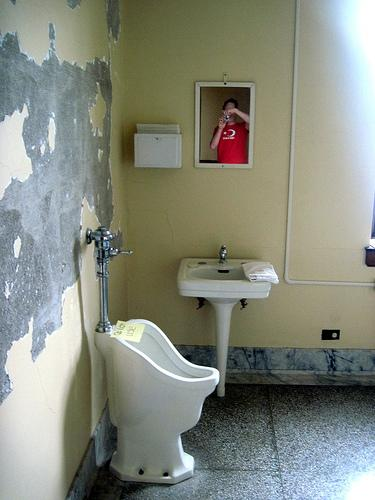Which object is doing an action and what is that action within the image description? The man in the mirror is performing the action of taking a photo. Provide a brief description of the scene in the image. The image shows a bathroom with a white urinal, a pedestal sink, a mirror, and a floor with grey patches. There is a yellow out-of-order sign on the urinal and a man's reflection in the mirror. Explain the appearance of the floor in the image using adjectives. The floor in this image is dark, speckled, and cracked, with grey patches. How many elements in the image description relate to the state of the wall and what are a few keywords relating to them? Six elements relate to the state of the wall: light-colored wall, wall with peeled paint, paint chipped on the wall, the water pipe on the wall, edge of the window sill, and grey mottled section of the wall. Keywords include light-colored, peeled, chipped, water pipe, window sill, and grey mottled. List any two objects and describe their interactions with another object in the image. 2. Bar of soap: resting on the sink, presumably used for washing hands. Describe the sentiments that could be associated with the image. Sentiments associated with the image may include disrepair, uncleanliness, and frustration, as the urinal is out of order and there is peeling paint on the walls. In one sentence, sum up what can be inferred from the image's reflection in the mirror. A man wearing a red t-shirt is taking a photo of the bathroom's reflection in the mirror. How many different objects are mentioned as being on the sink? Three objects are mentioned on the sink: bar of soap, folded towel, and a silver faucet. What is the main object visible in the image and in which corner of the image can it be primarily found? The main object visible is a white urinal, and it can be found at the left side of the image near the bottom. Count and mention how many objects are connected to the floor in the image. There are three objects connected to the floor: urinal, pedestal sink, and the faux marble wide baseboard. Identify the type of floor in the image. Speckled tiled floor Point out some objects you can see in the image. White urinal, pedestal sink, man's reflection in the mirror, towel, faucet, floor with gray patches, outlet, and paper towel holder. What do you notice about the condition of the wall in the image? There are chipped and peeling paint areas on the wall. Is the metal faucet for a sink or a urinal in the image? Sink Identify parts or sections of the wall in the image. Wall with peeled paint, gray mottled section of wall, and paint chipped on the wall. Locate the toothbrush and toothpaste lying beside the bar of soap on the sink. The image captions mention a bar of soap on the sink, but there is no mention of a toothbrush or toothpaste. This instruction is misleading because it directs users to find non-existent objects. Find the rubber duck sitting on the edge of the bathtub, and notice its vibrant yellow color. The image captions do not contain any information about a rubber duck or a bathtub, making this instruction misleading as it directs users to locate non-existent objects. What type of object can you find at the coordinates X:131 Y:460 Width:18 Height:18? Bolt holding toilet to floor What color is the man's shirt in the mirror reflection? Red Observe the beautiful blue mosaic tiles on the wall, creating an eye-catching pattern behind the urinal. No, it's not mentioned in the image. List the attributes of the faucet in the image. The faucet is metal and silver-colored. What is on the side of the sink in the image? Towel What objects are interacting with the sink? Faucet, towel, and bar of soap Describe the urinal in the image. The urinal is white, connected to the floor, has a yellow sign on it, and has a silver flusher attached to it. What material is the baseboard made of? Faux marble Match the phrase "yellow sign on urinal" with its coordinates in the image. X:105 Y:310 Width:49 Height:49 Are there any texts visible in the image? There might be text on the yellow sign on the urinal, but it is not clearly visible. What object can you see at the coordinate X:357 Y:179 Width:17 Height:17? Edge of window sill What are the relationships between the objects in the image? Urinal for use, sink for washing hands, faucet delivers water to sink, towel and soap for drying and cleaning, and man is a user of the restroom. Is the mood of the image positive or negative? Neutral Evaluate the quality of the image. The image quality is good with clear and sharp objects. Are there any unusual elements in the image? Paint chipped on the wall, crack in the floor, and peeled paint on the wall. 